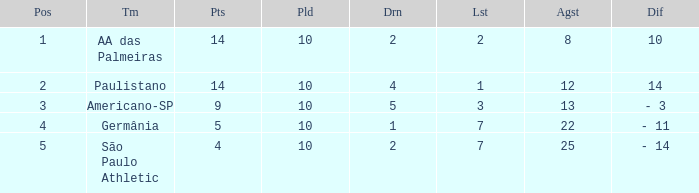What is the Against when the drawn is 5? 13.0. 